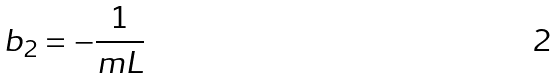Convert formula to latex. <formula><loc_0><loc_0><loc_500><loc_500>b _ { 2 } = - \frac { 1 } { m L }</formula> 